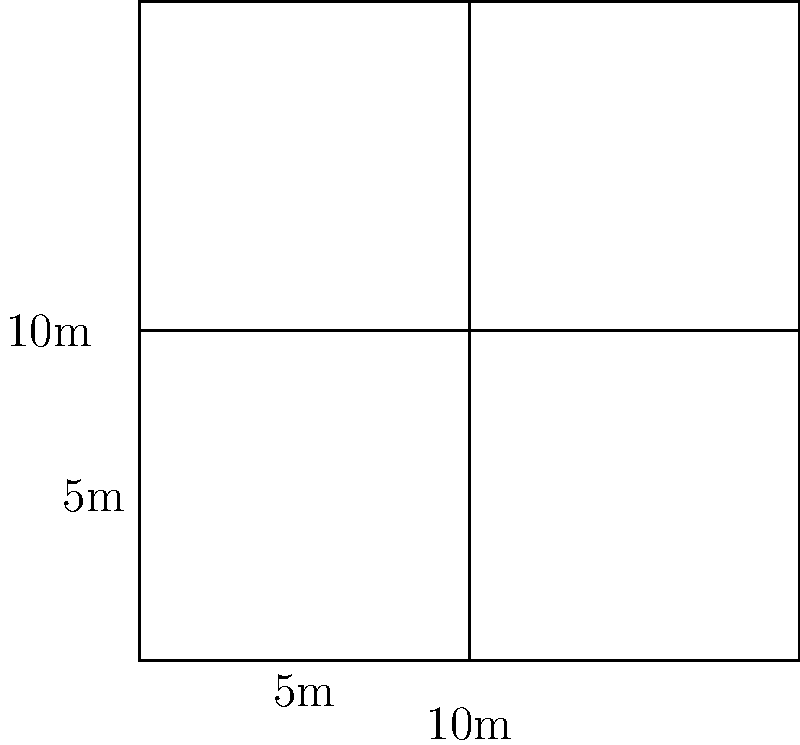As the village chief, you need to calculate the total fenced area for a new cattle pen layout. The layout consists of four square pens arranged in a 2x2 grid, each pen measuring 5m x 5m. What is the total perimeter of fencing needed to enclose all four pens together as one large square pen? Let's approach this step-by-step:

1) First, we need to understand the layout:
   - We have 4 square pens, each 5m x 5m
   - They are arranged in a 2x2 grid, forming a larger square

2) The total dimensions of the large square:
   - Width = 5m + 5m = 10m
   - Height = 5m + 5m = 10m

3) To calculate the perimeter, we use the formula:
   $$ \text{Perimeter} = 4 \times \text{side length} $$

4) In this case, the side length of the large square is 10m, so:
   $$ \text{Perimeter} = 4 \times 10\text{m} = 40\text{m} $$

Therefore, the total perimeter of fencing needed is 40 meters.
Answer: 40 meters 